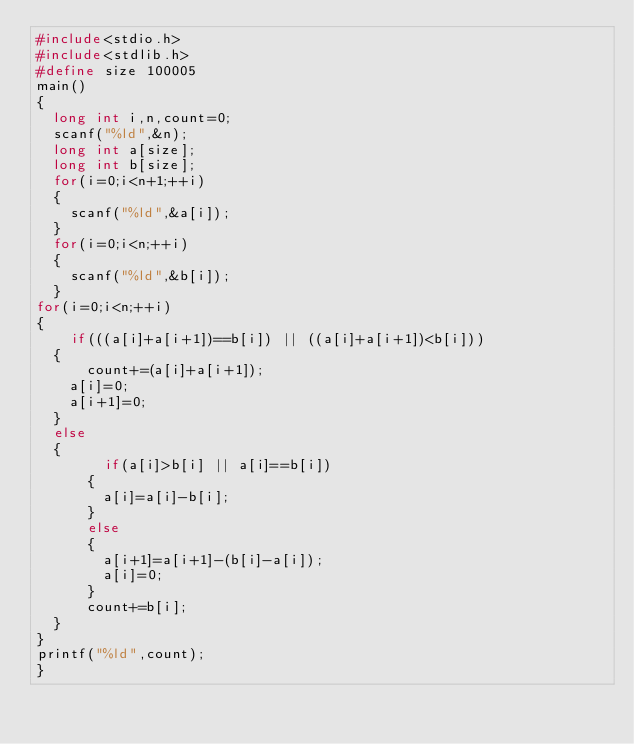<code> <loc_0><loc_0><loc_500><loc_500><_C_>#include<stdio.h>
#include<stdlib.h>
#define size 100005
main()
{
	long int i,n,count=0;
	scanf("%ld",&n);
	long int a[size];
	long int b[size];
	for(i=0;i<n+1;++i)
	{
		scanf("%ld",&a[i]);
	}
	for(i=0;i<n;++i)
	{
		scanf("%ld",&b[i]);
	}
for(i=0;i<n;++i)
{
    if(((a[i]+a[i+1])==b[i]) || ((a[i]+a[i+1])<b[i]))
	{
	    count+=(a[i]+a[i+1]);
		a[i]=0;
		a[i+1]=0;	
	}
	else
	{
	      if(a[i]>b[i] || a[i]==b[i])
		  {
		    a[i]=a[i]-b[i];	
		  }
		  else
		  {
		  	a[i+1]=a[i+1]-(b[i]-a[i]); 	
		    a[i]=0;
		  }
		  count+=b[i];	
	}	
}
printf("%ld",count);
}</code> 